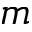Convert formula to latex. <formula><loc_0><loc_0><loc_500><loc_500>m</formula> 